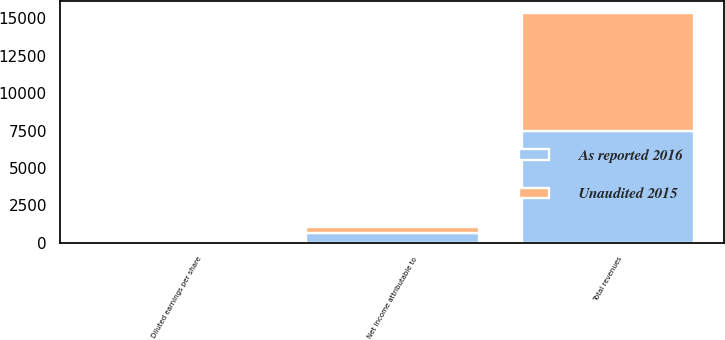Convert chart to OTSL. <chart><loc_0><loc_0><loc_500><loc_500><stacked_bar_chart><ecel><fcel>Total revenues<fcel>Net income attributable to<fcel>Diluted earnings per share<nl><fcel>Unaudited 2015<fcel>7887<fcel>420<fcel>3.04<nl><fcel>As reported 2016<fcel>7492<fcel>640<fcel>4.64<nl></chart> 